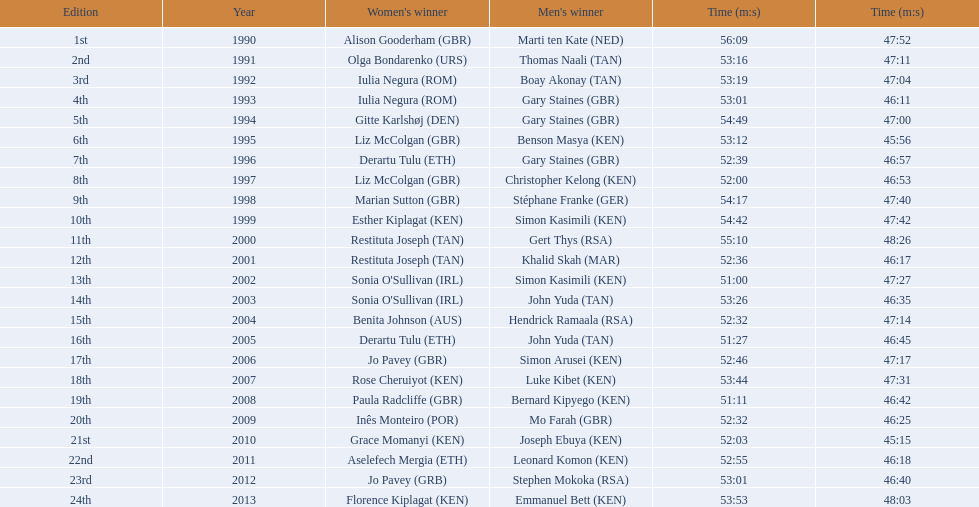Which of the runner in the great south run were women? Alison Gooderham (GBR), Olga Bondarenko (URS), Iulia Negura (ROM), Iulia Negura (ROM), Gitte Karlshøj (DEN), Liz McColgan (GBR), Derartu Tulu (ETH), Liz McColgan (GBR), Marian Sutton (GBR), Esther Kiplagat (KEN), Restituta Joseph (TAN), Restituta Joseph (TAN), Sonia O'Sullivan (IRL), Sonia O'Sullivan (IRL), Benita Johnson (AUS), Derartu Tulu (ETH), Jo Pavey (GBR), Rose Cheruiyot (KEN), Paula Radcliffe (GBR), Inês Monteiro (POR), Grace Momanyi (KEN), Aselefech Mergia (ETH), Jo Pavey (GRB), Florence Kiplagat (KEN). Of those women, which ones had a time of at least 53 minutes? Alison Gooderham (GBR), Olga Bondarenko (URS), Iulia Negura (ROM), Iulia Negura (ROM), Gitte Karlshøj (DEN), Liz McColgan (GBR), Marian Sutton (GBR), Esther Kiplagat (KEN), Restituta Joseph (TAN), Sonia O'Sullivan (IRL), Rose Cheruiyot (KEN), Jo Pavey (GRB), Florence Kiplagat (KEN). Between those women, which ones did not go over 53 minutes? Olga Bondarenko (URS), Iulia Negura (ROM), Iulia Negura (ROM), Liz McColgan (GBR), Sonia O'Sullivan (IRL), Rose Cheruiyot (KEN), Jo Pavey (GRB), Florence Kiplagat (KEN). Of those 8, what were the three slowest times? Sonia O'Sullivan (IRL), Rose Cheruiyot (KEN), Florence Kiplagat (KEN). Between only those 3 women, which runner had the fastest time? Sonia O'Sullivan (IRL). What was this women's time? 53:26. 